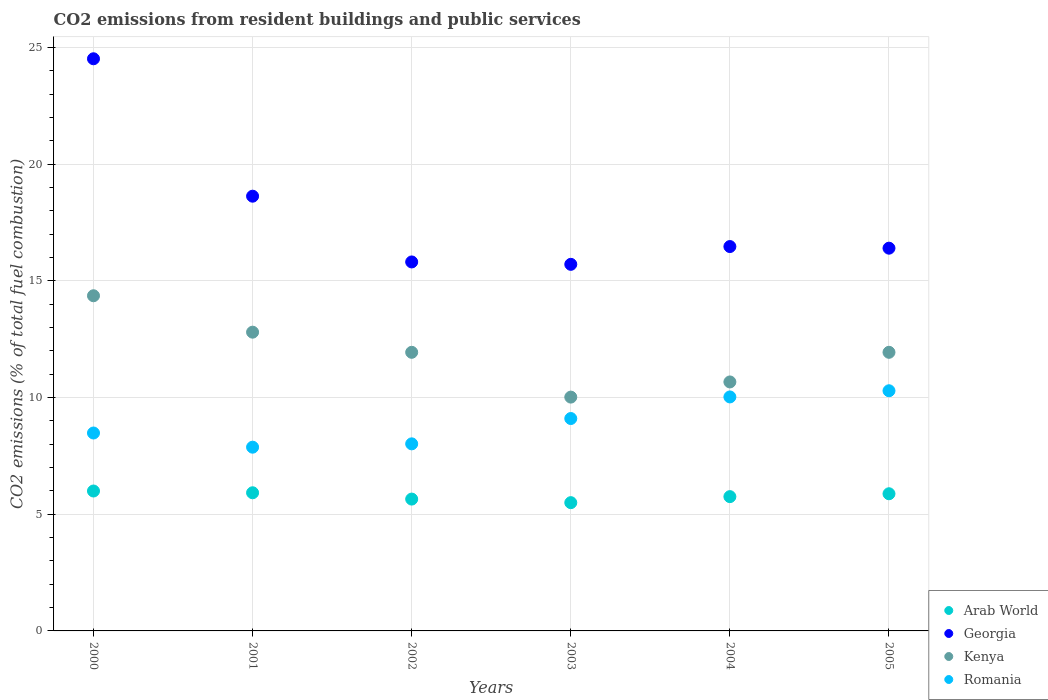How many different coloured dotlines are there?
Provide a short and direct response. 4. Is the number of dotlines equal to the number of legend labels?
Ensure brevity in your answer.  Yes. What is the total CO2 emitted in Kenya in 2003?
Provide a succinct answer. 10.02. Across all years, what is the maximum total CO2 emitted in Arab World?
Make the answer very short. 5.99. Across all years, what is the minimum total CO2 emitted in Romania?
Keep it short and to the point. 7.87. What is the total total CO2 emitted in Romania in the graph?
Provide a succinct answer. 53.78. What is the difference between the total CO2 emitted in Romania in 2001 and that in 2002?
Ensure brevity in your answer.  -0.14. What is the difference between the total CO2 emitted in Georgia in 2002 and the total CO2 emitted in Arab World in 2001?
Ensure brevity in your answer.  9.89. What is the average total CO2 emitted in Kenya per year?
Your response must be concise. 11.95. In the year 2003, what is the difference between the total CO2 emitted in Kenya and total CO2 emitted in Romania?
Provide a short and direct response. 0.92. In how many years, is the total CO2 emitted in Georgia greater than 22?
Your answer should be very brief. 1. What is the ratio of the total CO2 emitted in Kenya in 2004 to that in 2005?
Keep it short and to the point. 0.89. What is the difference between the highest and the second highest total CO2 emitted in Romania?
Give a very brief answer. 0.26. What is the difference between the highest and the lowest total CO2 emitted in Kenya?
Offer a terse response. 4.34. Is the sum of the total CO2 emitted in Georgia in 2003 and 2005 greater than the maximum total CO2 emitted in Romania across all years?
Your answer should be compact. Yes. Is it the case that in every year, the sum of the total CO2 emitted in Georgia and total CO2 emitted in Romania  is greater than the total CO2 emitted in Kenya?
Offer a very short reply. Yes. Is the total CO2 emitted in Kenya strictly greater than the total CO2 emitted in Georgia over the years?
Make the answer very short. No. Is the total CO2 emitted in Arab World strictly less than the total CO2 emitted in Romania over the years?
Ensure brevity in your answer.  Yes. How many dotlines are there?
Your answer should be compact. 4. How many years are there in the graph?
Your response must be concise. 6. Does the graph contain any zero values?
Provide a short and direct response. No. Where does the legend appear in the graph?
Your answer should be compact. Bottom right. How many legend labels are there?
Offer a terse response. 4. What is the title of the graph?
Keep it short and to the point. CO2 emissions from resident buildings and public services. What is the label or title of the Y-axis?
Your answer should be compact. CO2 emissions (% of total fuel combustion). What is the CO2 emissions (% of total fuel combustion) in Arab World in 2000?
Provide a short and direct response. 5.99. What is the CO2 emissions (% of total fuel combustion) of Georgia in 2000?
Provide a short and direct response. 24.51. What is the CO2 emissions (% of total fuel combustion) in Kenya in 2000?
Provide a short and direct response. 14.36. What is the CO2 emissions (% of total fuel combustion) of Romania in 2000?
Your answer should be very brief. 8.48. What is the CO2 emissions (% of total fuel combustion) in Arab World in 2001?
Provide a succinct answer. 5.92. What is the CO2 emissions (% of total fuel combustion) of Georgia in 2001?
Provide a succinct answer. 18.62. What is the CO2 emissions (% of total fuel combustion) of Kenya in 2001?
Your answer should be compact. 12.8. What is the CO2 emissions (% of total fuel combustion) of Romania in 2001?
Keep it short and to the point. 7.87. What is the CO2 emissions (% of total fuel combustion) of Arab World in 2002?
Offer a terse response. 5.65. What is the CO2 emissions (% of total fuel combustion) of Georgia in 2002?
Provide a short and direct response. 15.81. What is the CO2 emissions (% of total fuel combustion) of Kenya in 2002?
Make the answer very short. 11.94. What is the CO2 emissions (% of total fuel combustion) in Romania in 2002?
Offer a very short reply. 8.01. What is the CO2 emissions (% of total fuel combustion) of Arab World in 2003?
Make the answer very short. 5.5. What is the CO2 emissions (% of total fuel combustion) in Georgia in 2003?
Your answer should be very brief. 15.71. What is the CO2 emissions (% of total fuel combustion) of Kenya in 2003?
Ensure brevity in your answer.  10.02. What is the CO2 emissions (% of total fuel combustion) of Romania in 2003?
Your answer should be very brief. 9.1. What is the CO2 emissions (% of total fuel combustion) in Arab World in 2004?
Your response must be concise. 5.75. What is the CO2 emissions (% of total fuel combustion) in Georgia in 2004?
Give a very brief answer. 16.47. What is the CO2 emissions (% of total fuel combustion) in Kenya in 2004?
Make the answer very short. 10.67. What is the CO2 emissions (% of total fuel combustion) in Romania in 2004?
Your answer should be compact. 10.02. What is the CO2 emissions (% of total fuel combustion) in Arab World in 2005?
Provide a short and direct response. 5.88. What is the CO2 emissions (% of total fuel combustion) of Georgia in 2005?
Offer a very short reply. 16.4. What is the CO2 emissions (% of total fuel combustion) of Kenya in 2005?
Provide a succinct answer. 11.94. What is the CO2 emissions (% of total fuel combustion) in Romania in 2005?
Provide a short and direct response. 10.29. Across all years, what is the maximum CO2 emissions (% of total fuel combustion) in Arab World?
Your response must be concise. 5.99. Across all years, what is the maximum CO2 emissions (% of total fuel combustion) of Georgia?
Your response must be concise. 24.51. Across all years, what is the maximum CO2 emissions (% of total fuel combustion) of Kenya?
Your answer should be very brief. 14.36. Across all years, what is the maximum CO2 emissions (% of total fuel combustion) in Romania?
Your response must be concise. 10.29. Across all years, what is the minimum CO2 emissions (% of total fuel combustion) in Arab World?
Offer a very short reply. 5.5. Across all years, what is the minimum CO2 emissions (% of total fuel combustion) in Georgia?
Your answer should be compact. 15.71. Across all years, what is the minimum CO2 emissions (% of total fuel combustion) of Kenya?
Your answer should be very brief. 10.02. Across all years, what is the minimum CO2 emissions (% of total fuel combustion) in Romania?
Your answer should be compact. 7.87. What is the total CO2 emissions (% of total fuel combustion) in Arab World in the graph?
Make the answer very short. 34.69. What is the total CO2 emissions (% of total fuel combustion) in Georgia in the graph?
Keep it short and to the point. 107.51. What is the total CO2 emissions (% of total fuel combustion) in Kenya in the graph?
Provide a succinct answer. 71.71. What is the total CO2 emissions (% of total fuel combustion) in Romania in the graph?
Your answer should be very brief. 53.78. What is the difference between the CO2 emissions (% of total fuel combustion) of Arab World in 2000 and that in 2001?
Your answer should be compact. 0.08. What is the difference between the CO2 emissions (% of total fuel combustion) in Georgia in 2000 and that in 2001?
Ensure brevity in your answer.  5.89. What is the difference between the CO2 emissions (% of total fuel combustion) in Kenya in 2000 and that in 2001?
Your answer should be compact. 1.56. What is the difference between the CO2 emissions (% of total fuel combustion) in Romania in 2000 and that in 2001?
Provide a short and direct response. 0.61. What is the difference between the CO2 emissions (% of total fuel combustion) in Arab World in 2000 and that in 2002?
Keep it short and to the point. 0.35. What is the difference between the CO2 emissions (% of total fuel combustion) in Georgia in 2000 and that in 2002?
Offer a terse response. 8.7. What is the difference between the CO2 emissions (% of total fuel combustion) in Kenya in 2000 and that in 2002?
Keep it short and to the point. 2.42. What is the difference between the CO2 emissions (% of total fuel combustion) of Romania in 2000 and that in 2002?
Give a very brief answer. 0.46. What is the difference between the CO2 emissions (% of total fuel combustion) in Arab World in 2000 and that in 2003?
Keep it short and to the point. 0.5. What is the difference between the CO2 emissions (% of total fuel combustion) in Georgia in 2000 and that in 2003?
Ensure brevity in your answer.  8.81. What is the difference between the CO2 emissions (% of total fuel combustion) in Kenya in 2000 and that in 2003?
Give a very brief answer. 4.34. What is the difference between the CO2 emissions (% of total fuel combustion) of Romania in 2000 and that in 2003?
Your answer should be compact. -0.62. What is the difference between the CO2 emissions (% of total fuel combustion) in Arab World in 2000 and that in 2004?
Ensure brevity in your answer.  0.24. What is the difference between the CO2 emissions (% of total fuel combustion) of Georgia in 2000 and that in 2004?
Give a very brief answer. 8.04. What is the difference between the CO2 emissions (% of total fuel combustion) of Kenya in 2000 and that in 2004?
Keep it short and to the point. 3.69. What is the difference between the CO2 emissions (% of total fuel combustion) in Romania in 2000 and that in 2004?
Ensure brevity in your answer.  -1.55. What is the difference between the CO2 emissions (% of total fuel combustion) in Arab World in 2000 and that in 2005?
Ensure brevity in your answer.  0.12. What is the difference between the CO2 emissions (% of total fuel combustion) in Georgia in 2000 and that in 2005?
Provide a short and direct response. 8.11. What is the difference between the CO2 emissions (% of total fuel combustion) of Kenya in 2000 and that in 2005?
Keep it short and to the point. 2.42. What is the difference between the CO2 emissions (% of total fuel combustion) of Romania in 2000 and that in 2005?
Keep it short and to the point. -1.81. What is the difference between the CO2 emissions (% of total fuel combustion) in Arab World in 2001 and that in 2002?
Your response must be concise. 0.27. What is the difference between the CO2 emissions (% of total fuel combustion) in Georgia in 2001 and that in 2002?
Ensure brevity in your answer.  2.82. What is the difference between the CO2 emissions (% of total fuel combustion) of Kenya in 2001 and that in 2002?
Keep it short and to the point. 0.86. What is the difference between the CO2 emissions (% of total fuel combustion) of Romania in 2001 and that in 2002?
Your answer should be compact. -0.14. What is the difference between the CO2 emissions (% of total fuel combustion) of Arab World in 2001 and that in 2003?
Your response must be concise. 0.42. What is the difference between the CO2 emissions (% of total fuel combustion) in Georgia in 2001 and that in 2003?
Offer a very short reply. 2.92. What is the difference between the CO2 emissions (% of total fuel combustion) of Kenya in 2001 and that in 2003?
Your answer should be compact. 2.78. What is the difference between the CO2 emissions (% of total fuel combustion) in Romania in 2001 and that in 2003?
Your answer should be very brief. -1.23. What is the difference between the CO2 emissions (% of total fuel combustion) of Arab World in 2001 and that in 2004?
Provide a succinct answer. 0.17. What is the difference between the CO2 emissions (% of total fuel combustion) in Georgia in 2001 and that in 2004?
Provide a short and direct response. 2.16. What is the difference between the CO2 emissions (% of total fuel combustion) of Kenya in 2001 and that in 2004?
Offer a very short reply. 2.13. What is the difference between the CO2 emissions (% of total fuel combustion) of Romania in 2001 and that in 2004?
Keep it short and to the point. -2.15. What is the difference between the CO2 emissions (% of total fuel combustion) of Arab World in 2001 and that in 2005?
Your answer should be very brief. 0.04. What is the difference between the CO2 emissions (% of total fuel combustion) of Georgia in 2001 and that in 2005?
Offer a terse response. 2.23. What is the difference between the CO2 emissions (% of total fuel combustion) of Kenya in 2001 and that in 2005?
Give a very brief answer. 0.86. What is the difference between the CO2 emissions (% of total fuel combustion) in Romania in 2001 and that in 2005?
Provide a short and direct response. -2.42. What is the difference between the CO2 emissions (% of total fuel combustion) in Arab World in 2002 and that in 2003?
Offer a very short reply. 0.15. What is the difference between the CO2 emissions (% of total fuel combustion) of Georgia in 2002 and that in 2003?
Keep it short and to the point. 0.1. What is the difference between the CO2 emissions (% of total fuel combustion) in Kenya in 2002 and that in 2003?
Give a very brief answer. 1.92. What is the difference between the CO2 emissions (% of total fuel combustion) of Romania in 2002 and that in 2003?
Ensure brevity in your answer.  -1.08. What is the difference between the CO2 emissions (% of total fuel combustion) in Arab World in 2002 and that in 2004?
Make the answer very short. -0.1. What is the difference between the CO2 emissions (% of total fuel combustion) of Georgia in 2002 and that in 2004?
Your answer should be very brief. -0.66. What is the difference between the CO2 emissions (% of total fuel combustion) of Kenya in 2002 and that in 2004?
Offer a terse response. 1.27. What is the difference between the CO2 emissions (% of total fuel combustion) of Romania in 2002 and that in 2004?
Your answer should be compact. -2.01. What is the difference between the CO2 emissions (% of total fuel combustion) of Arab World in 2002 and that in 2005?
Give a very brief answer. -0.23. What is the difference between the CO2 emissions (% of total fuel combustion) in Georgia in 2002 and that in 2005?
Your answer should be very brief. -0.59. What is the difference between the CO2 emissions (% of total fuel combustion) of Kenya in 2002 and that in 2005?
Offer a very short reply. -0. What is the difference between the CO2 emissions (% of total fuel combustion) in Romania in 2002 and that in 2005?
Provide a short and direct response. -2.27. What is the difference between the CO2 emissions (% of total fuel combustion) in Arab World in 2003 and that in 2004?
Offer a very short reply. -0.26. What is the difference between the CO2 emissions (% of total fuel combustion) in Georgia in 2003 and that in 2004?
Offer a very short reply. -0.76. What is the difference between the CO2 emissions (% of total fuel combustion) in Kenya in 2003 and that in 2004?
Make the answer very short. -0.65. What is the difference between the CO2 emissions (% of total fuel combustion) of Romania in 2003 and that in 2004?
Provide a short and direct response. -0.93. What is the difference between the CO2 emissions (% of total fuel combustion) in Arab World in 2003 and that in 2005?
Offer a very short reply. -0.38. What is the difference between the CO2 emissions (% of total fuel combustion) in Georgia in 2003 and that in 2005?
Keep it short and to the point. -0.69. What is the difference between the CO2 emissions (% of total fuel combustion) in Kenya in 2003 and that in 2005?
Your answer should be very brief. -1.92. What is the difference between the CO2 emissions (% of total fuel combustion) in Romania in 2003 and that in 2005?
Provide a short and direct response. -1.19. What is the difference between the CO2 emissions (% of total fuel combustion) in Arab World in 2004 and that in 2005?
Your response must be concise. -0.12. What is the difference between the CO2 emissions (% of total fuel combustion) in Georgia in 2004 and that in 2005?
Give a very brief answer. 0.07. What is the difference between the CO2 emissions (% of total fuel combustion) in Kenya in 2004 and that in 2005?
Provide a succinct answer. -1.27. What is the difference between the CO2 emissions (% of total fuel combustion) of Romania in 2004 and that in 2005?
Offer a very short reply. -0.26. What is the difference between the CO2 emissions (% of total fuel combustion) of Arab World in 2000 and the CO2 emissions (% of total fuel combustion) of Georgia in 2001?
Provide a short and direct response. -12.63. What is the difference between the CO2 emissions (% of total fuel combustion) of Arab World in 2000 and the CO2 emissions (% of total fuel combustion) of Kenya in 2001?
Provide a short and direct response. -6.8. What is the difference between the CO2 emissions (% of total fuel combustion) of Arab World in 2000 and the CO2 emissions (% of total fuel combustion) of Romania in 2001?
Ensure brevity in your answer.  -1.88. What is the difference between the CO2 emissions (% of total fuel combustion) of Georgia in 2000 and the CO2 emissions (% of total fuel combustion) of Kenya in 2001?
Your answer should be very brief. 11.71. What is the difference between the CO2 emissions (% of total fuel combustion) in Georgia in 2000 and the CO2 emissions (% of total fuel combustion) in Romania in 2001?
Give a very brief answer. 16.64. What is the difference between the CO2 emissions (% of total fuel combustion) of Kenya in 2000 and the CO2 emissions (% of total fuel combustion) of Romania in 2001?
Provide a short and direct response. 6.49. What is the difference between the CO2 emissions (% of total fuel combustion) in Arab World in 2000 and the CO2 emissions (% of total fuel combustion) in Georgia in 2002?
Offer a terse response. -9.81. What is the difference between the CO2 emissions (% of total fuel combustion) of Arab World in 2000 and the CO2 emissions (% of total fuel combustion) of Kenya in 2002?
Provide a succinct answer. -5.94. What is the difference between the CO2 emissions (% of total fuel combustion) in Arab World in 2000 and the CO2 emissions (% of total fuel combustion) in Romania in 2002?
Provide a succinct answer. -2.02. What is the difference between the CO2 emissions (% of total fuel combustion) of Georgia in 2000 and the CO2 emissions (% of total fuel combustion) of Kenya in 2002?
Your response must be concise. 12.58. What is the difference between the CO2 emissions (% of total fuel combustion) in Georgia in 2000 and the CO2 emissions (% of total fuel combustion) in Romania in 2002?
Provide a short and direct response. 16.5. What is the difference between the CO2 emissions (% of total fuel combustion) of Kenya in 2000 and the CO2 emissions (% of total fuel combustion) of Romania in 2002?
Make the answer very short. 6.34. What is the difference between the CO2 emissions (% of total fuel combustion) in Arab World in 2000 and the CO2 emissions (% of total fuel combustion) in Georgia in 2003?
Offer a very short reply. -9.71. What is the difference between the CO2 emissions (% of total fuel combustion) in Arab World in 2000 and the CO2 emissions (% of total fuel combustion) in Kenya in 2003?
Provide a succinct answer. -4.02. What is the difference between the CO2 emissions (% of total fuel combustion) in Arab World in 2000 and the CO2 emissions (% of total fuel combustion) in Romania in 2003?
Your response must be concise. -3.11. What is the difference between the CO2 emissions (% of total fuel combustion) in Georgia in 2000 and the CO2 emissions (% of total fuel combustion) in Kenya in 2003?
Ensure brevity in your answer.  14.49. What is the difference between the CO2 emissions (% of total fuel combustion) of Georgia in 2000 and the CO2 emissions (% of total fuel combustion) of Romania in 2003?
Give a very brief answer. 15.41. What is the difference between the CO2 emissions (% of total fuel combustion) in Kenya in 2000 and the CO2 emissions (% of total fuel combustion) in Romania in 2003?
Give a very brief answer. 5.26. What is the difference between the CO2 emissions (% of total fuel combustion) of Arab World in 2000 and the CO2 emissions (% of total fuel combustion) of Georgia in 2004?
Offer a very short reply. -10.47. What is the difference between the CO2 emissions (% of total fuel combustion) in Arab World in 2000 and the CO2 emissions (% of total fuel combustion) in Kenya in 2004?
Offer a terse response. -4.67. What is the difference between the CO2 emissions (% of total fuel combustion) in Arab World in 2000 and the CO2 emissions (% of total fuel combustion) in Romania in 2004?
Keep it short and to the point. -4.03. What is the difference between the CO2 emissions (% of total fuel combustion) of Georgia in 2000 and the CO2 emissions (% of total fuel combustion) of Kenya in 2004?
Your answer should be very brief. 13.85. What is the difference between the CO2 emissions (% of total fuel combustion) in Georgia in 2000 and the CO2 emissions (% of total fuel combustion) in Romania in 2004?
Keep it short and to the point. 14.49. What is the difference between the CO2 emissions (% of total fuel combustion) in Kenya in 2000 and the CO2 emissions (% of total fuel combustion) in Romania in 2004?
Provide a succinct answer. 4.33. What is the difference between the CO2 emissions (% of total fuel combustion) of Arab World in 2000 and the CO2 emissions (% of total fuel combustion) of Georgia in 2005?
Give a very brief answer. -10.4. What is the difference between the CO2 emissions (% of total fuel combustion) of Arab World in 2000 and the CO2 emissions (% of total fuel combustion) of Kenya in 2005?
Your response must be concise. -5.94. What is the difference between the CO2 emissions (% of total fuel combustion) in Arab World in 2000 and the CO2 emissions (% of total fuel combustion) in Romania in 2005?
Ensure brevity in your answer.  -4.29. What is the difference between the CO2 emissions (% of total fuel combustion) of Georgia in 2000 and the CO2 emissions (% of total fuel combustion) of Kenya in 2005?
Provide a succinct answer. 12.58. What is the difference between the CO2 emissions (% of total fuel combustion) in Georgia in 2000 and the CO2 emissions (% of total fuel combustion) in Romania in 2005?
Keep it short and to the point. 14.22. What is the difference between the CO2 emissions (% of total fuel combustion) of Kenya in 2000 and the CO2 emissions (% of total fuel combustion) of Romania in 2005?
Provide a short and direct response. 4.07. What is the difference between the CO2 emissions (% of total fuel combustion) of Arab World in 2001 and the CO2 emissions (% of total fuel combustion) of Georgia in 2002?
Give a very brief answer. -9.89. What is the difference between the CO2 emissions (% of total fuel combustion) of Arab World in 2001 and the CO2 emissions (% of total fuel combustion) of Kenya in 2002?
Offer a very short reply. -6.02. What is the difference between the CO2 emissions (% of total fuel combustion) in Arab World in 2001 and the CO2 emissions (% of total fuel combustion) in Romania in 2002?
Provide a succinct answer. -2.1. What is the difference between the CO2 emissions (% of total fuel combustion) of Georgia in 2001 and the CO2 emissions (% of total fuel combustion) of Kenya in 2002?
Offer a very short reply. 6.69. What is the difference between the CO2 emissions (% of total fuel combustion) of Georgia in 2001 and the CO2 emissions (% of total fuel combustion) of Romania in 2002?
Provide a short and direct response. 10.61. What is the difference between the CO2 emissions (% of total fuel combustion) of Kenya in 2001 and the CO2 emissions (% of total fuel combustion) of Romania in 2002?
Provide a short and direct response. 4.78. What is the difference between the CO2 emissions (% of total fuel combustion) in Arab World in 2001 and the CO2 emissions (% of total fuel combustion) in Georgia in 2003?
Your answer should be very brief. -9.79. What is the difference between the CO2 emissions (% of total fuel combustion) in Arab World in 2001 and the CO2 emissions (% of total fuel combustion) in Kenya in 2003?
Your response must be concise. -4.1. What is the difference between the CO2 emissions (% of total fuel combustion) of Arab World in 2001 and the CO2 emissions (% of total fuel combustion) of Romania in 2003?
Ensure brevity in your answer.  -3.18. What is the difference between the CO2 emissions (% of total fuel combustion) in Georgia in 2001 and the CO2 emissions (% of total fuel combustion) in Kenya in 2003?
Keep it short and to the point. 8.61. What is the difference between the CO2 emissions (% of total fuel combustion) in Georgia in 2001 and the CO2 emissions (% of total fuel combustion) in Romania in 2003?
Give a very brief answer. 9.53. What is the difference between the CO2 emissions (% of total fuel combustion) of Kenya in 2001 and the CO2 emissions (% of total fuel combustion) of Romania in 2003?
Give a very brief answer. 3.7. What is the difference between the CO2 emissions (% of total fuel combustion) of Arab World in 2001 and the CO2 emissions (% of total fuel combustion) of Georgia in 2004?
Offer a very short reply. -10.55. What is the difference between the CO2 emissions (% of total fuel combustion) of Arab World in 2001 and the CO2 emissions (% of total fuel combustion) of Kenya in 2004?
Ensure brevity in your answer.  -4.75. What is the difference between the CO2 emissions (% of total fuel combustion) in Arab World in 2001 and the CO2 emissions (% of total fuel combustion) in Romania in 2004?
Provide a short and direct response. -4.11. What is the difference between the CO2 emissions (% of total fuel combustion) in Georgia in 2001 and the CO2 emissions (% of total fuel combustion) in Kenya in 2004?
Your answer should be compact. 7.96. What is the difference between the CO2 emissions (% of total fuel combustion) of Georgia in 2001 and the CO2 emissions (% of total fuel combustion) of Romania in 2004?
Your response must be concise. 8.6. What is the difference between the CO2 emissions (% of total fuel combustion) in Kenya in 2001 and the CO2 emissions (% of total fuel combustion) in Romania in 2004?
Your answer should be compact. 2.77. What is the difference between the CO2 emissions (% of total fuel combustion) of Arab World in 2001 and the CO2 emissions (% of total fuel combustion) of Georgia in 2005?
Offer a very short reply. -10.48. What is the difference between the CO2 emissions (% of total fuel combustion) in Arab World in 2001 and the CO2 emissions (% of total fuel combustion) in Kenya in 2005?
Give a very brief answer. -6.02. What is the difference between the CO2 emissions (% of total fuel combustion) of Arab World in 2001 and the CO2 emissions (% of total fuel combustion) of Romania in 2005?
Your answer should be compact. -4.37. What is the difference between the CO2 emissions (% of total fuel combustion) in Georgia in 2001 and the CO2 emissions (% of total fuel combustion) in Kenya in 2005?
Give a very brief answer. 6.69. What is the difference between the CO2 emissions (% of total fuel combustion) of Georgia in 2001 and the CO2 emissions (% of total fuel combustion) of Romania in 2005?
Provide a short and direct response. 8.34. What is the difference between the CO2 emissions (% of total fuel combustion) of Kenya in 2001 and the CO2 emissions (% of total fuel combustion) of Romania in 2005?
Keep it short and to the point. 2.51. What is the difference between the CO2 emissions (% of total fuel combustion) in Arab World in 2002 and the CO2 emissions (% of total fuel combustion) in Georgia in 2003?
Your response must be concise. -10.06. What is the difference between the CO2 emissions (% of total fuel combustion) of Arab World in 2002 and the CO2 emissions (% of total fuel combustion) of Kenya in 2003?
Make the answer very short. -4.37. What is the difference between the CO2 emissions (% of total fuel combustion) of Arab World in 2002 and the CO2 emissions (% of total fuel combustion) of Romania in 2003?
Your answer should be very brief. -3.45. What is the difference between the CO2 emissions (% of total fuel combustion) in Georgia in 2002 and the CO2 emissions (% of total fuel combustion) in Kenya in 2003?
Offer a terse response. 5.79. What is the difference between the CO2 emissions (% of total fuel combustion) of Georgia in 2002 and the CO2 emissions (% of total fuel combustion) of Romania in 2003?
Offer a terse response. 6.71. What is the difference between the CO2 emissions (% of total fuel combustion) of Kenya in 2002 and the CO2 emissions (% of total fuel combustion) of Romania in 2003?
Your response must be concise. 2.84. What is the difference between the CO2 emissions (% of total fuel combustion) in Arab World in 2002 and the CO2 emissions (% of total fuel combustion) in Georgia in 2004?
Make the answer very short. -10.82. What is the difference between the CO2 emissions (% of total fuel combustion) in Arab World in 2002 and the CO2 emissions (% of total fuel combustion) in Kenya in 2004?
Provide a succinct answer. -5.02. What is the difference between the CO2 emissions (% of total fuel combustion) in Arab World in 2002 and the CO2 emissions (% of total fuel combustion) in Romania in 2004?
Make the answer very short. -4.38. What is the difference between the CO2 emissions (% of total fuel combustion) of Georgia in 2002 and the CO2 emissions (% of total fuel combustion) of Kenya in 2004?
Your answer should be very brief. 5.14. What is the difference between the CO2 emissions (% of total fuel combustion) of Georgia in 2002 and the CO2 emissions (% of total fuel combustion) of Romania in 2004?
Ensure brevity in your answer.  5.78. What is the difference between the CO2 emissions (% of total fuel combustion) in Kenya in 2002 and the CO2 emissions (% of total fuel combustion) in Romania in 2004?
Ensure brevity in your answer.  1.91. What is the difference between the CO2 emissions (% of total fuel combustion) of Arab World in 2002 and the CO2 emissions (% of total fuel combustion) of Georgia in 2005?
Offer a very short reply. -10.75. What is the difference between the CO2 emissions (% of total fuel combustion) of Arab World in 2002 and the CO2 emissions (% of total fuel combustion) of Kenya in 2005?
Ensure brevity in your answer.  -6.29. What is the difference between the CO2 emissions (% of total fuel combustion) in Arab World in 2002 and the CO2 emissions (% of total fuel combustion) in Romania in 2005?
Your answer should be compact. -4.64. What is the difference between the CO2 emissions (% of total fuel combustion) of Georgia in 2002 and the CO2 emissions (% of total fuel combustion) of Kenya in 2005?
Provide a short and direct response. 3.87. What is the difference between the CO2 emissions (% of total fuel combustion) of Georgia in 2002 and the CO2 emissions (% of total fuel combustion) of Romania in 2005?
Provide a succinct answer. 5.52. What is the difference between the CO2 emissions (% of total fuel combustion) in Kenya in 2002 and the CO2 emissions (% of total fuel combustion) in Romania in 2005?
Give a very brief answer. 1.65. What is the difference between the CO2 emissions (% of total fuel combustion) of Arab World in 2003 and the CO2 emissions (% of total fuel combustion) of Georgia in 2004?
Your answer should be very brief. -10.97. What is the difference between the CO2 emissions (% of total fuel combustion) of Arab World in 2003 and the CO2 emissions (% of total fuel combustion) of Kenya in 2004?
Give a very brief answer. -5.17. What is the difference between the CO2 emissions (% of total fuel combustion) of Arab World in 2003 and the CO2 emissions (% of total fuel combustion) of Romania in 2004?
Your response must be concise. -4.53. What is the difference between the CO2 emissions (% of total fuel combustion) in Georgia in 2003 and the CO2 emissions (% of total fuel combustion) in Kenya in 2004?
Give a very brief answer. 5.04. What is the difference between the CO2 emissions (% of total fuel combustion) of Georgia in 2003 and the CO2 emissions (% of total fuel combustion) of Romania in 2004?
Your answer should be compact. 5.68. What is the difference between the CO2 emissions (% of total fuel combustion) in Kenya in 2003 and the CO2 emissions (% of total fuel combustion) in Romania in 2004?
Ensure brevity in your answer.  -0.01. What is the difference between the CO2 emissions (% of total fuel combustion) of Arab World in 2003 and the CO2 emissions (% of total fuel combustion) of Georgia in 2005?
Offer a very short reply. -10.9. What is the difference between the CO2 emissions (% of total fuel combustion) in Arab World in 2003 and the CO2 emissions (% of total fuel combustion) in Kenya in 2005?
Your response must be concise. -6.44. What is the difference between the CO2 emissions (% of total fuel combustion) of Arab World in 2003 and the CO2 emissions (% of total fuel combustion) of Romania in 2005?
Ensure brevity in your answer.  -4.79. What is the difference between the CO2 emissions (% of total fuel combustion) in Georgia in 2003 and the CO2 emissions (% of total fuel combustion) in Kenya in 2005?
Ensure brevity in your answer.  3.77. What is the difference between the CO2 emissions (% of total fuel combustion) of Georgia in 2003 and the CO2 emissions (% of total fuel combustion) of Romania in 2005?
Offer a very short reply. 5.42. What is the difference between the CO2 emissions (% of total fuel combustion) in Kenya in 2003 and the CO2 emissions (% of total fuel combustion) in Romania in 2005?
Provide a succinct answer. -0.27. What is the difference between the CO2 emissions (% of total fuel combustion) in Arab World in 2004 and the CO2 emissions (% of total fuel combustion) in Georgia in 2005?
Offer a very short reply. -10.64. What is the difference between the CO2 emissions (% of total fuel combustion) in Arab World in 2004 and the CO2 emissions (% of total fuel combustion) in Kenya in 2005?
Ensure brevity in your answer.  -6.18. What is the difference between the CO2 emissions (% of total fuel combustion) in Arab World in 2004 and the CO2 emissions (% of total fuel combustion) in Romania in 2005?
Give a very brief answer. -4.54. What is the difference between the CO2 emissions (% of total fuel combustion) of Georgia in 2004 and the CO2 emissions (% of total fuel combustion) of Kenya in 2005?
Make the answer very short. 4.53. What is the difference between the CO2 emissions (% of total fuel combustion) in Georgia in 2004 and the CO2 emissions (% of total fuel combustion) in Romania in 2005?
Give a very brief answer. 6.18. What is the difference between the CO2 emissions (% of total fuel combustion) in Kenya in 2004 and the CO2 emissions (% of total fuel combustion) in Romania in 2005?
Give a very brief answer. 0.38. What is the average CO2 emissions (% of total fuel combustion) in Arab World per year?
Your answer should be compact. 5.78. What is the average CO2 emissions (% of total fuel combustion) in Georgia per year?
Give a very brief answer. 17.92. What is the average CO2 emissions (% of total fuel combustion) in Kenya per year?
Offer a terse response. 11.95. What is the average CO2 emissions (% of total fuel combustion) of Romania per year?
Give a very brief answer. 8.96. In the year 2000, what is the difference between the CO2 emissions (% of total fuel combustion) in Arab World and CO2 emissions (% of total fuel combustion) in Georgia?
Your answer should be very brief. -18.52. In the year 2000, what is the difference between the CO2 emissions (% of total fuel combustion) of Arab World and CO2 emissions (% of total fuel combustion) of Kenya?
Make the answer very short. -8.37. In the year 2000, what is the difference between the CO2 emissions (% of total fuel combustion) in Arab World and CO2 emissions (% of total fuel combustion) in Romania?
Make the answer very short. -2.48. In the year 2000, what is the difference between the CO2 emissions (% of total fuel combustion) of Georgia and CO2 emissions (% of total fuel combustion) of Kenya?
Your response must be concise. 10.15. In the year 2000, what is the difference between the CO2 emissions (% of total fuel combustion) in Georgia and CO2 emissions (% of total fuel combustion) in Romania?
Provide a short and direct response. 16.03. In the year 2000, what is the difference between the CO2 emissions (% of total fuel combustion) in Kenya and CO2 emissions (% of total fuel combustion) in Romania?
Ensure brevity in your answer.  5.88. In the year 2001, what is the difference between the CO2 emissions (% of total fuel combustion) of Arab World and CO2 emissions (% of total fuel combustion) of Georgia?
Keep it short and to the point. -12.71. In the year 2001, what is the difference between the CO2 emissions (% of total fuel combustion) in Arab World and CO2 emissions (% of total fuel combustion) in Kenya?
Offer a terse response. -6.88. In the year 2001, what is the difference between the CO2 emissions (% of total fuel combustion) of Arab World and CO2 emissions (% of total fuel combustion) of Romania?
Your response must be concise. -1.95. In the year 2001, what is the difference between the CO2 emissions (% of total fuel combustion) in Georgia and CO2 emissions (% of total fuel combustion) in Kenya?
Keep it short and to the point. 5.83. In the year 2001, what is the difference between the CO2 emissions (% of total fuel combustion) of Georgia and CO2 emissions (% of total fuel combustion) of Romania?
Your answer should be compact. 10.75. In the year 2001, what is the difference between the CO2 emissions (% of total fuel combustion) in Kenya and CO2 emissions (% of total fuel combustion) in Romania?
Your answer should be compact. 4.93. In the year 2002, what is the difference between the CO2 emissions (% of total fuel combustion) in Arab World and CO2 emissions (% of total fuel combustion) in Georgia?
Keep it short and to the point. -10.16. In the year 2002, what is the difference between the CO2 emissions (% of total fuel combustion) of Arab World and CO2 emissions (% of total fuel combustion) of Kenya?
Your response must be concise. -6.29. In the year 2002, what is the difference between the CO2 emissions (% of total fuel combustion) of Arab World and CO2 emissions (% of total fuel combustion) of Romania?
Provide a short and direct response. -2.37. In the year 2002, what is the difference between the CO2 emissions (% of total fuel combustion) of Georgia and CO2 emissions (% of total fuel combustion) of Kenya?
Offer a terse response. 3.87. In the year 2002, what is the difference between the CO2 emissions (% of total fuel combustion) in Georgia and CO2 emissions (% of total fuel combustion) in Romania?
Your response must be concise. 7.79. In the year 2002, what is the difference between the CO2 emissions (% of total fuel combustion) of Kenya and CO2 emissions (% of total fuel combustion) of Romania?
Provide a succinct answer. 3.92. In the year 2003, what is the difference between the CO2 emissions (% of total fuel combustion) of Arab World and CO2 emissions (% of total fuel combustion) of Georgia?
Give a very brief answer. -10.21. In the year 2003, what is the difference between the CO2 emissions (% of total fuel combustion) in Arab World and CO2 emissions (% of total fuel combustion) in Kenya?
Your answer should be compact. -4.52. In the year 2003, what is the difference between the CO2 emissions (% of total fuel combustion) of Arab World and CO2 emissions (% of total fuel combustion) of Romania?
Offer a very short reply. -3.6. In the year 2003, what is the difference between the CO2 emissions (% of total fuel combustion) of Georgia and CO2 emissions (% of total fuel combustion) of Kenya?
Provide a succinct answer. 5.69. In the year 2003, what is the difference between the CO2 emissions (% of total fuel combustion) of Georgia and CO2 emissions (% of total fuel combustion) of Romania?
Ensure brevity in your answer.  6.61. In the year 2003, what is the difference between the CO2 emissions (% of total fuel combustion) of Kenya and CO2 emissions (% of total fuel combustion) of Romania?
Make the answer very short. 0.92. In the year 2004, what is the difference between the CO2 emissions (% of total fuel combustion) in Arab World and CO2 emissions (% of total fuel combustion) in Georgia?
Your answer should be very brief. -10.71. In the year 2004, what is the difference between the CO2 emissions (% of total fuel combustion) of Arab World and CO2 emissions (% of total fuel combustion) of Kenya?
Offer a very short reply. -4.91. In the year 2004, what is the difference between the CO2 emissions (% of total fuel combustion) of Arab World and CO2 emissions (% of total fuel combustion) of Romania?
Provide a succinct answer. -4.27. In the year 2004, what is the difference between the CO2 emissions (% of total fuel combustion) of Georgia and CO2 emissions (% of total fuel combustion) of Kenya?
Your answer should be compact. 5.8. In the year 2004, what is the difference between the CO2 emissions (% of total fuel combustion) of Georgia and CO2 emissions (% of total fuel combustion) of Romania?
Ensure brevity in your answer.  6.44. In the year 2004, what is the difference between the CO2 emissions (% of total fuel combustion) in Kenya and CO2 emissions (% of total fuel combustion) in Romania?
Your response must be concise. 0.64. In the year 2005, what is the difference between the CO2 emissions (% of total fuel combustion) in Arab World and CO2 emissions (% of total fuel combustion) in Georgia?
Provide a short and direct response. -10.52. In the year 2005, what is the difference between the CO2 emissions (% of total fuel combustion) in Arab World and CO2 emissions (% of total fuel combustion) in Kenya?
Keep it short and to the point. -6.06. In the year 2005, what is the difference between the CO2 emissions (% of total fuel combustion) of Arab World and CO2 emissions (% of total fuel combustion) of Romania?
Provide a short and direct response. -4.41. In the year 2005, what is the difference between the CO2 emissions (% of total fuel combustion) of Georgia and CO2 emissions (% of total fuel combustion) of Kenya?
Your answer should be compact. 4.46. In the year 2005, what is the difference between the CO2 emissions (% of total fuel combustion) of Georgia and CO2 emissions (% of total fuel combustion) of Romania?
Provide a short and direct response. 6.11. In the year 2005, what is the difference between the CO2 emissions (% of total fuel combustion) in Kenya and CO2 emissions (% of total fuel combustion) in Romania?
Your answer should be compact. 1.65. What is the ratio of the CO2 emissions (% of total fuel combustion) of Arab World in 2000 to that in 2001?
Keep it short and to the point. 1.01. What is the ratio of the CO2 emissions (% of total fuel combustion) in Georgia in 2000 to that in 2001?
Offer a terse response. 1.32. What is the ratio of the CO2 emissions (% of total fuel combustion) in Kenya in 2000 to that in 2001?
Give a very brief answer. 1.12. What is the ratio of the CO2 emissions (% of total fuel combustion) in Romania in 2000 to that in 2001?
Give a very brief answer. 1.08. What is the ratio of the CO2 emissions (% of total fuel combustion) in Arab World in 2000 to that in 2002?
Ensure brevity in your answer.  1.06. What is the ratio of the CO2 emissions (% of total fuel combustion) in Georgia in 2000 to that in 2002?
Your answer should be compact. 1.55. What is the ratio of the CO2 emissions (% of total fuel combustion) of Kenya in 2000 to that in 2002?
Keep it short and to the point. 1.2. What is the ratio of the CO2 emissions (% of total fuel combustion) in Romania in 2000 to that in 2002?
Offer a very short reply. 1.06. What is the ratio of the CO2 emissions (% of total fuel combustion) of Arab World in 2000 to that in 2003?
Offer a very short reply. 1.09. What is the ratio of the CO2 emissions (% of total fuel combustion) in Georgia in 2000 to that in 2003?
Your answer should be very brief. 1.56. What is the ratio of the CO2 emissions (% of total fuel combustion) in Kenya in 2000 to that in 2003?
Offer a terse response. 1.43. What is the ratio of the CO2 emissions (% of total fuel combustion) of Romania in 2000 to that in 2003?
Provide a succinct answer. 0.93. What is the ratio of the CO2 emissions (% of total fuel combustion) in Arab World in 2000 to that in 2004?
Keep it short and to the point. 1.04. What is the ratio of the CO2 emissions (% of total fuel combustion) in Georgia in 2000 to that in 2004?
Keep it short and to the point. 1.49. What is the ratio of the CO2 emissions (% of total fuel combustion) in Kenya in 2000 to that in 2004?
Offer a terse response. 1.35. What is the ratio of the CO2 emissions (% of total fuel combustion) of Romania in 2000 to that in 2004?
Provide a short and direct response. 0.85. What is the ratio of the CO2 emissions (% of total fuel combustion) in Georgia in 2000 to that in 2005?
Ensure brevity in your answer.  1.49. What is the ratio of the CO2 emissions (% of total fuel combustion) of Kenya in 2000 to that in 2005?
Offer a very short reply. 1.2. What is the ratio of the CO2 emissions (% of total fuel combustion) in Romania in 2000 to that in 2005?
Make the answer very short. 0.82. What is the ratio of the CO2 emissions (% of total fuel combustion) of Arab World in 2001 to that in 2002?
Your answer should be compact. 1.05. What is the ratio of the CO2 emissions (% of total fuel combustion) of Georgia in 2001 to that in 2002?
Your response must be concise. 1.18. What is the ratio of the CO2 emissions (% of total fuel combustion) of Kenya in 2001 to that in 2002?
Your response must be concise. 1.07. What is the ratio of the CO2 emissions (% of total fuel combustion) in Romania in 2001 to that in 2002?
Ensure brevity in your answer.  0.98. What is the ratio of the CO2 emissions (% of total fuel combustion) in Arab World in 2001 to that in 2003?
Provide a short and direct response. 1.08. What is the ratio of the CO2 emissions (% of total fuel combustion) of Georgia in 2001 to that in 2003?
Your answer should be very brief. 1.19. What is the ratio of the CO2 emissions (% of total fuel combustion) of Kenya in 2001 to that in 2003?
Keep it short and to the point. 1.28. What is the ratio of the CO2 emissions (% of total fuel combustion) in Romania in 2001 to that in 2003?
Your answer should be compact. 0.87. What is the ratio of the CO2 emissions (% of total fuel combustion) of Arab World in 2001 to that in 2004?
Provide a succinct answer. 1.03. What is the ratio of the CO2 emissions (% of total fuel combustion) of Georgia in 2001 to that in 2004?
Your response must be concise. 1.13. What is the ratio of the CO2 emissions (% of total fuel combustion) in Kenya in 2001 to that in 2004?
Provide a succinct answer. 1.2. What is the ratio of the CO2 emissions (% of total fuel combustion) of Romania in 2001 to that in 2004?
Your answer should be compact. 0.79. What is the ratio of the CO2 emissions (% of total fuel combustion) in Arab World in 2001 to that in 2005?
Provide a short and direct response. 1.01. What is the ratio of the CO2 emissions (% of total fuel combustion) of Georgia in 2001 to that in 2005?
Make the answer very short. 1.14. What is the ratio of the CO2 emissions (% of total fuel combustion) in Kenya in 2001 to that in 2005?
Offer a terse response. 1.07. What is the ratio of the CO2 emissions (% of total fuel combustion) in Romania in 2001 to that in 2005?
Offer a very short reply. 0.77. What is the ratio of the CO2 emissions (% of total fuel combustion) of Arab World in 2002 to that in 2003?
Provide a short and direct response. 1.03. What is the ratio of the CO2 emissions (% of total fuel combustion) of Georgia in 2002 to that in 2003?
Provide a succinct answer. 1.01. What is the ratio of the CO2 emissions (% of total fuel combustion) in Kenya in 2002 to that in 2003?
Keep it short and to the point. 1.19. What is the ratio of the CO2 emissions (% of total fuel combustion) of Romania in 2002 to that in 2003?
Make the answer very short. 0.88. What is the ratio of the CO2 emissions (% of total fuel combustion) in Arab World in 2002 to that in 2004?
Make the answer very short. 0.98. What is the ratio of the CO2 emissions (% of total fuel combustion) in Kenya in 2002 to that in 2004?
Ensure brevity in your answer.  1.12. What is the ratio of the CO2 emissions (% of total fuel combustion) in Romania in 2002 to that in 2004?
Offer a terse response. 0.8. What is the ratio of the CO2 emissions (% of total fuel combustion) of Arab World in 2002 to that in 2005?
Offer a terse response. 0.96. What is the ratio of the CO2 emissions (% of total fuel combustion) of Romania in 2002 to that in 2005?
Provide a short and direct response. 0.78. What is the ratio of the CO2 emissions (% of total fuel combustion) of Arab World in 2003 to that in 2004?
Offer a terse response. 0.96. What is the ratio of the CO2 emissions (% of total fuel combustion) of Georgia in 2003 to that in 2004?
Make the answer very short. 0.95. What is the ratio of the CO2 emissions (% of total fuel combustion) in Kenya in 2003 to that in 2004?
Offer a very short reply. 0.94. What is the ratio of the CO2 emissions (% of total fuel combustion) of Romania in 2003 to that in 2004?
Offer a terse response. 0.91. What is the ratio of the CO2 emissions (% of total fuel combustion) in Arab World in 2003 to that in 2005?
Keep it short and to the point. 0.94. What is the ratio of the CO2 emissions (% of total fuel combustion) of Georgia in 2003 to that in 2005?
Ensure brevity in your answer.  0.96. What is the ratio of the CO2 emissions (% of total fuel combustion) of Kenya in 2003 to that in 2005?
Your response must be concise. 0.84. What is the ratio of the CO2 emissions (% of total fuel combustion) of Romania in 2003 to that in 2005?
Provide a succinct answer. 0.88. What is the ratio of the CO2 emissions (% of total fuel combustion) in Kenya in 2004 to that in 2005?
Give a very brief answer. 0.89. What is the ratio of the CO2 emissions (% of total fuel combustion) in Romania in 2004 to that in 2005?
Keep it short and to the point. 0.97. What is the difference between the highest and the second highest CO2 emissions (% of total fuel combustion) of Arab World?
Your answer should be compact. 0.08. What is the difference between the highest and the second highest CO2 emissions (% of total fuel combustion) in Georgia?
Your answer should be very brief. 5.89. What is the difference between the highest and the second highest CO2 emissions (% of total fuel combustion) of Kenya?
Provide a short and direct response. 1.56. What is the difference between the highest and the second highest CO2 emissions (% of total fuel combustion) in Romania?
Keep it short and to the point. 0.26. What is the difference between the highest and the lowest CO2 emissions (% of total fuel combustion) in Arab World?
Your response must be concise. 0.5. What is the difference between the highest and the lowest CO2 emissions (% of total fuel combustion) of Georgia?
Your answer should be compact. 8.81. What is the difference between the highest and the lowest CO2 emissions (% of total fuel combustion) of Kenya?
Make the answer very short. 4.34. What is the difference between the highest and the lowest CO2 emissions (% of total fuel combustion) of Romania?
Keep it short and to the point. 2.42. 